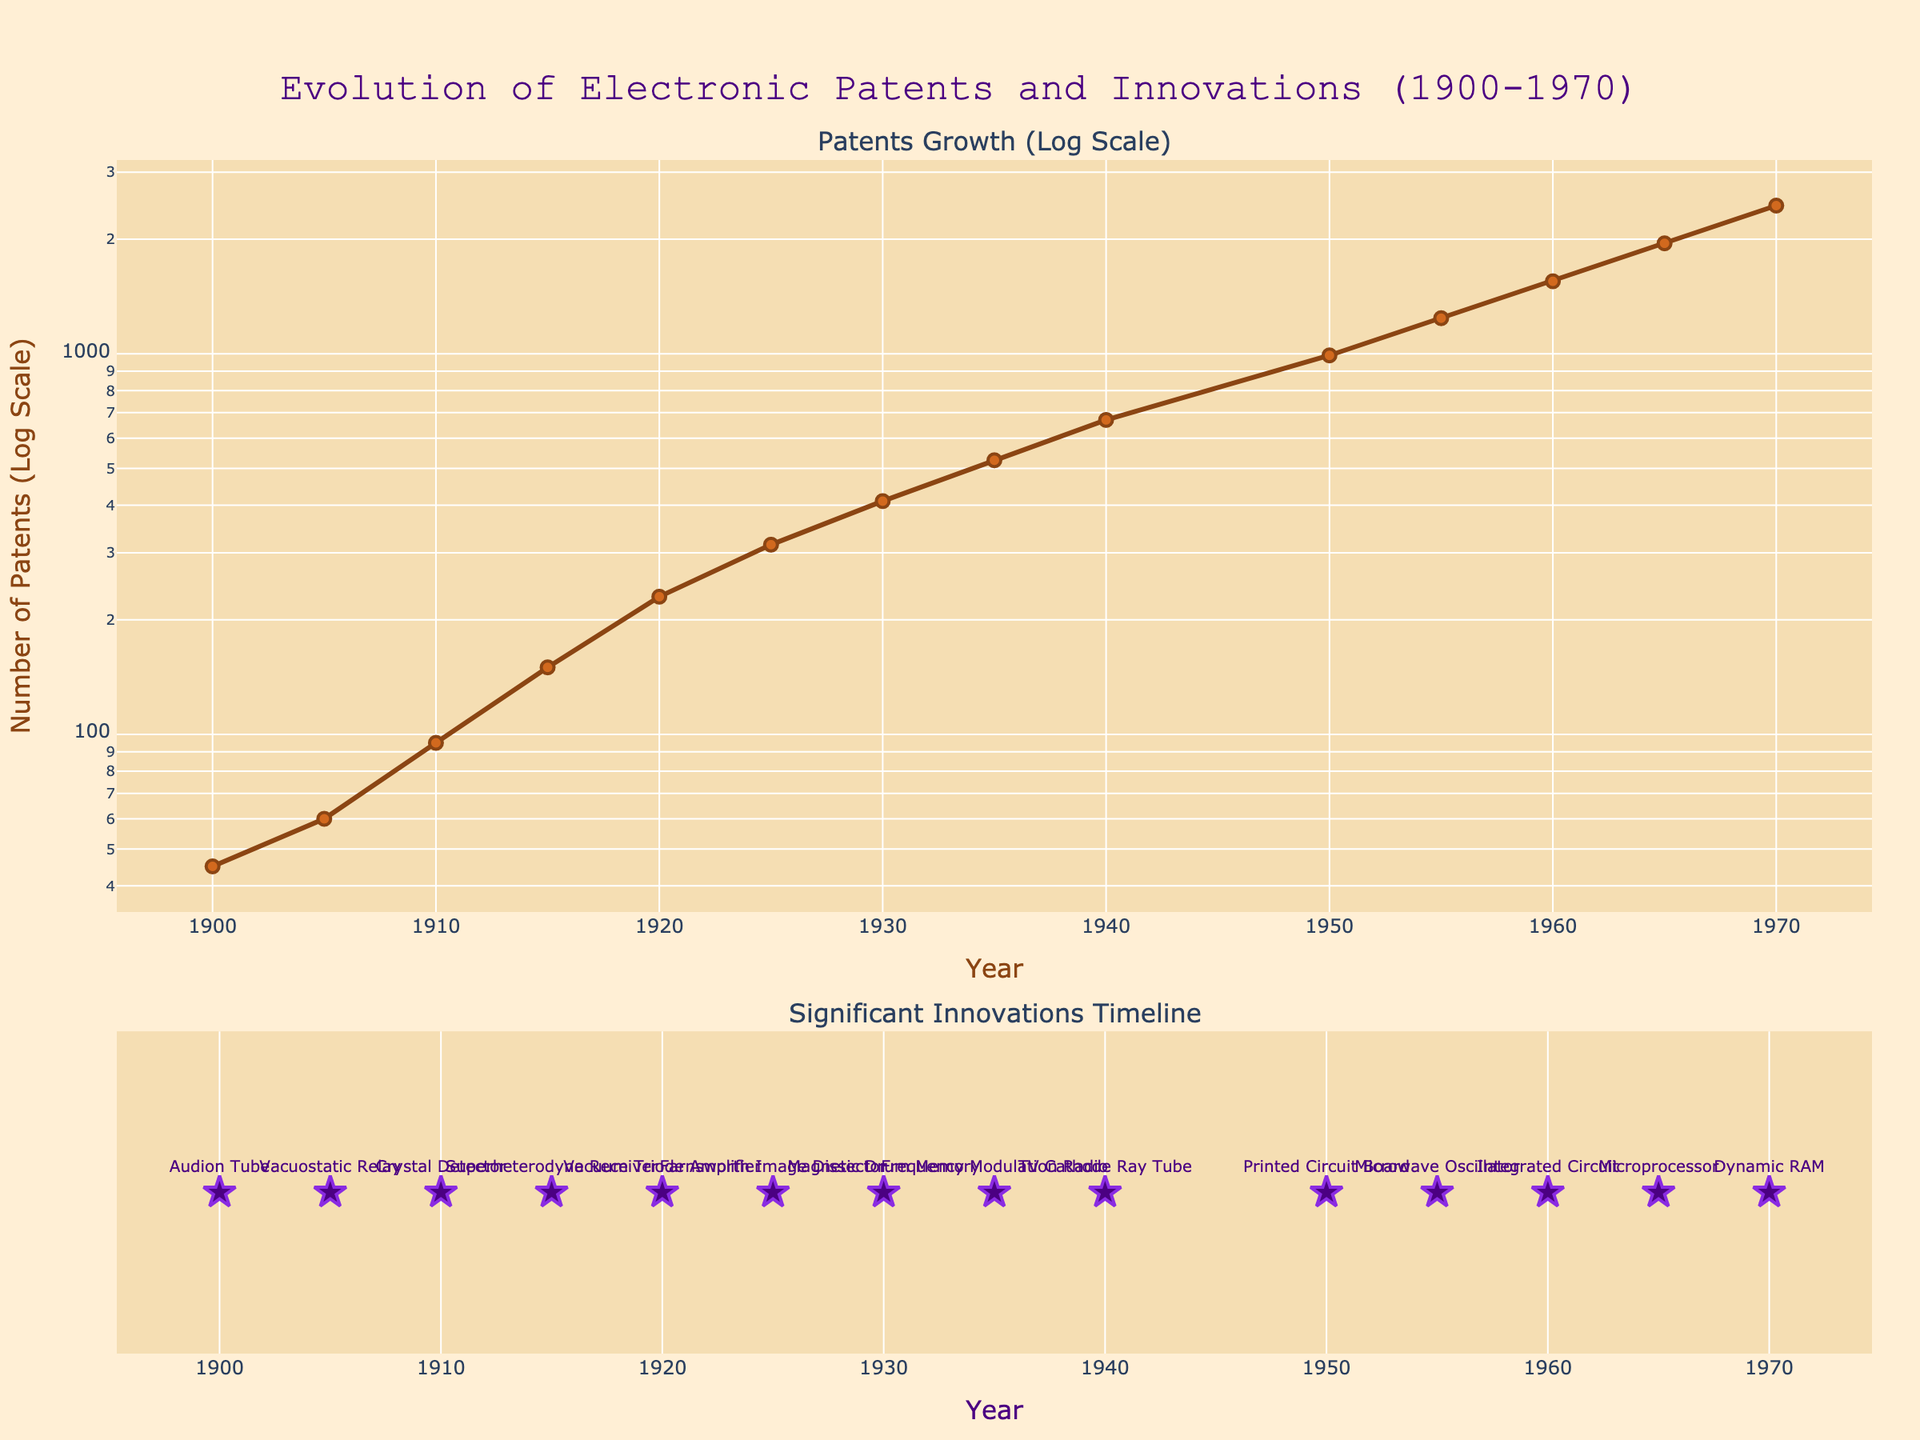What is the title of the plot? The title is displayed at the top of the plot. It reads "Evolution of Electronic Patents and Innovations (1900-1970)."
Answer: Evolution of Electronic Patents and Innovations (1900-1970) What is the range of years in the subplot showing patent growth? The x-axis of the first subplot, which shows patent growth, spans from 1900 to 1970. This range is marked on the x-axis at the bottom of this subplot.
Answer: 1900 to 1970 How many patents were documented in 1950? On the subplot that shows patent growth, locate the data point corresponding to the year 1950. The point aligns with approximately 990 patents on the y-axis.
Answer: 990 Which significant innovation is labeled for the year 1960? In the second subplot, the significant innovations are marked with stars. The text label for the year 1960 indicates the "Integrated Circuit."
Answer: Integrated Circuit Between which years did the number of patents increase by about 150? Compare the years and corresponding patent numbers in the first subplot. From 1915 (150 patents) to 1920 (230 patents), the increase is roughly 80 patents; from 1965 (1950 patents) to 1970 (2450 patents), the increase is about 500 patents. From 1930 (410 patents) to 1935 (525 patents), the increase is about 115 patents.
Answer: 1930 to 1935 What is unique about the scaling of the y-axis in the first subplot? The y-axis in the first subplot is log-scaled, which means the scale increases exponentially rather than linearly, providing better visualization of the growth rate over time.
Answer: Log scale How many significant innovations are marked in the second subplot? Counting the number of star markers in the second subplot provides the number of significant innovations. There are 14 markers.
Answer: 14 Which year was the magnet drum memory innovation marked? Locate the text labels in the second subplot for significant innovations. Magnetic Drum Memory corresponds to the year 1930.
Answer: 1930 